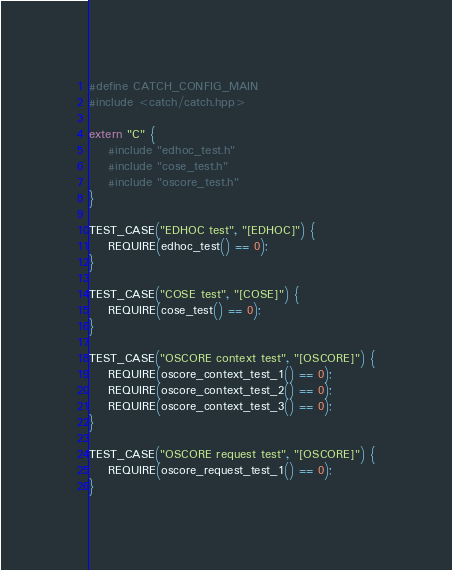Convert code to text. <code><loc_0><loc_0><loc_500><loc_500><_C++_>#define CATCH_CONFIG_MAIN
#include <catch/catch.hpp>

extern "C" {
    #include "edhoc_test.h"
    #include "cose_test.h"
    #include "oscore_test.h"
}

TEST_CASE("EDHOC test", "[EDHOC]") {
    REQUIRE(edhoc_test() == 0);
}

TEST_CASE("COSE test", "[COSE]") {
    REQUIRE(cose_test() == 0);
}

TEST_CASE("OSCORE context test", "[OSCORE]") {
    REQUIRE(oscore_context_test_1() == 0);
    REQUIRE(oscore_context_test_2() == 0);
    REQUIRE(oscore_context_test_3() == 0);
}

TEST_CASE("OSCORE request test", "[OSCORE]") {
    REQUIRE(oscore_request_test_1() == 0);
}
</code> 